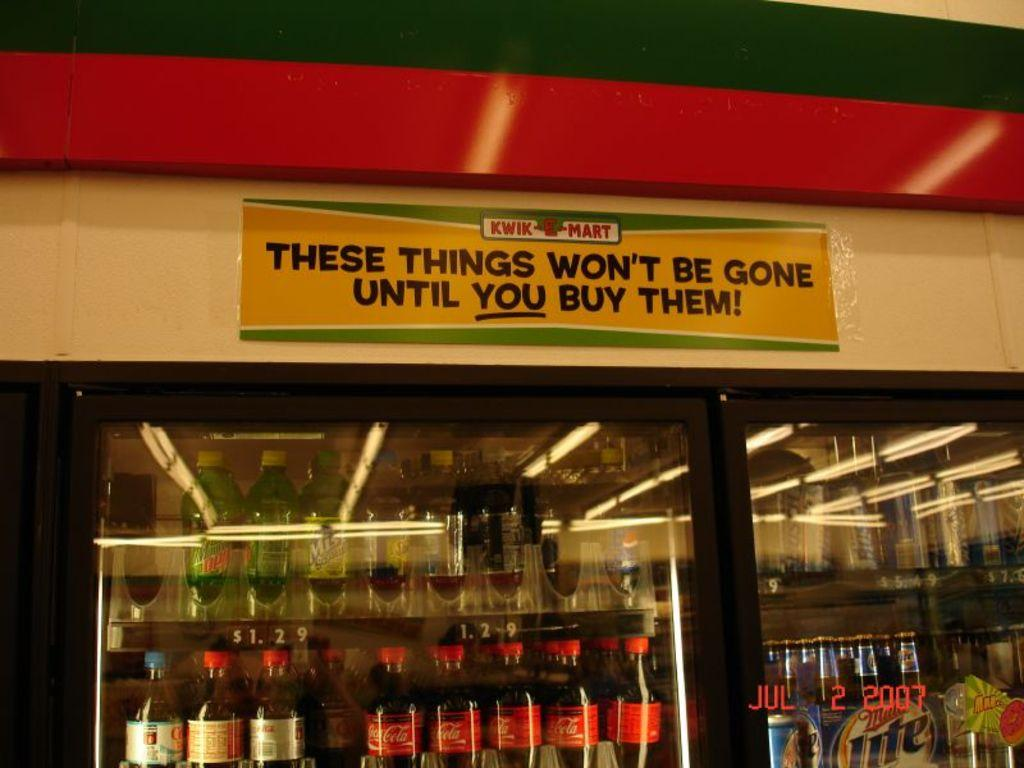<image>
Write a terse but informative summary of the picture. A Kwik Mart sign above a beverage cooler that says These things won't be gone until you buy them! 